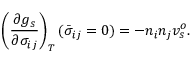<formula> <loc_0><loc_0><loc_500><loc_500>\left ( \frac { \partial g _ { s } } { \partial \sigma _ { i j } } \right ) _ { T } ( \bar { \sigma } _ { i j } = 0 ) = - n _ { i } n _ { j } v _ { s } ^ { o } .</formula> 